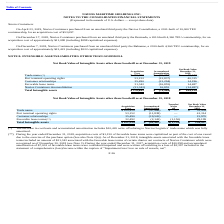According to Navios Maritime Holdings's financial document, What was the net book value of trade name? According to the financial document, 52,454 (in thousands). The relevant text states: "Trade name $ 100,420 $ (47,966) $ — $ 52,454..." Also, What was the acquisition cost of Port terminal operating rights? According to the financial document, 53,152 (in thousands). The relevant text states: "Port terminal operating rights 53,152 (11,838) — 41,314..." Also, What was the Accumulated Amortization of favorable lease terms? According to the financial document, (2,143) (in thousands). The relevant text states: "Favorable lease terms (**) 32,492 (2,143) (1,150) 29,199..." Also, How many intangible assets had an acquisition cost that exceeded $50,000 thousand? Counting the relevant items in the document: Trade name, Port terminal operating rights, I find 2 instances. The key data points involved are: Port terminal operating rights, Trade name. Also, can you calculate: What was the difference in the net book value between trade name and port terminal operating rights? Based on the calculation: 52,454-41,314, the result is 11140 (in thousands). This is based on the information: "Port terminal operating rights 53,152 (11,838) — 41,314 Trade name $ 100,420 $ (47,966) $ — $ 52,454..." The key data points involved are: 41,314, 52,454. Also, can you calculate: What was the difference between the accumulated amortization between Customer relationships and favorable lease terms? Based on the calculation: -19,520-(-2,143), the result is -17377 (in thousands). This is based on the information: "Favorable lease terms (**) 32,492 (2,143) (1,150) 29,199 Customer relationships 35,490 (19,520) — 15,970..." The key data points involved are: 19,520, 2,143. 